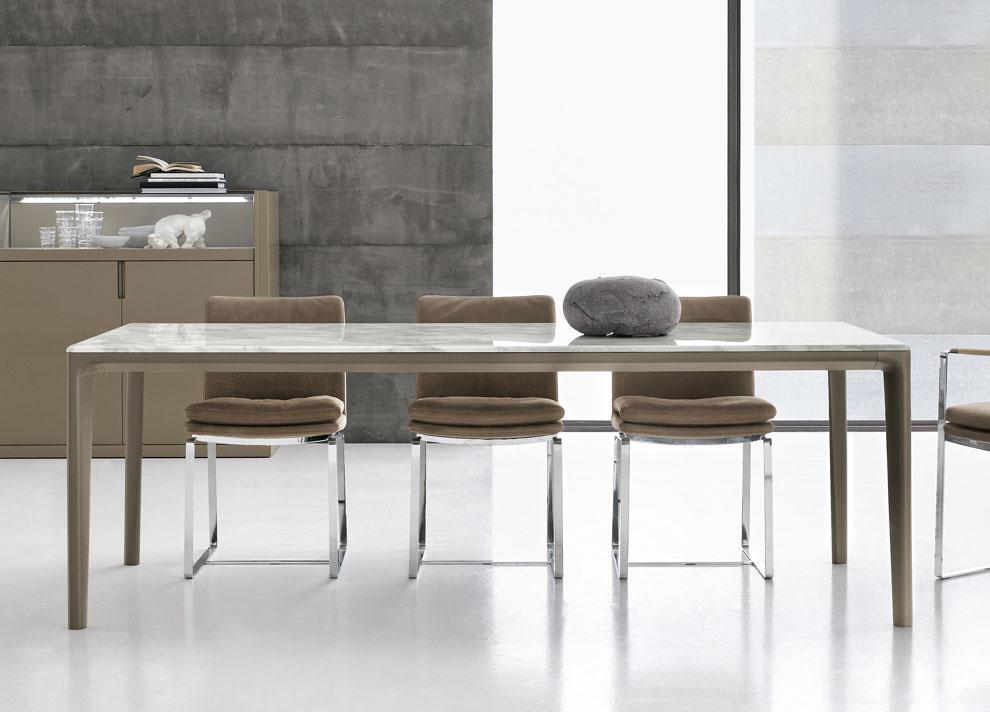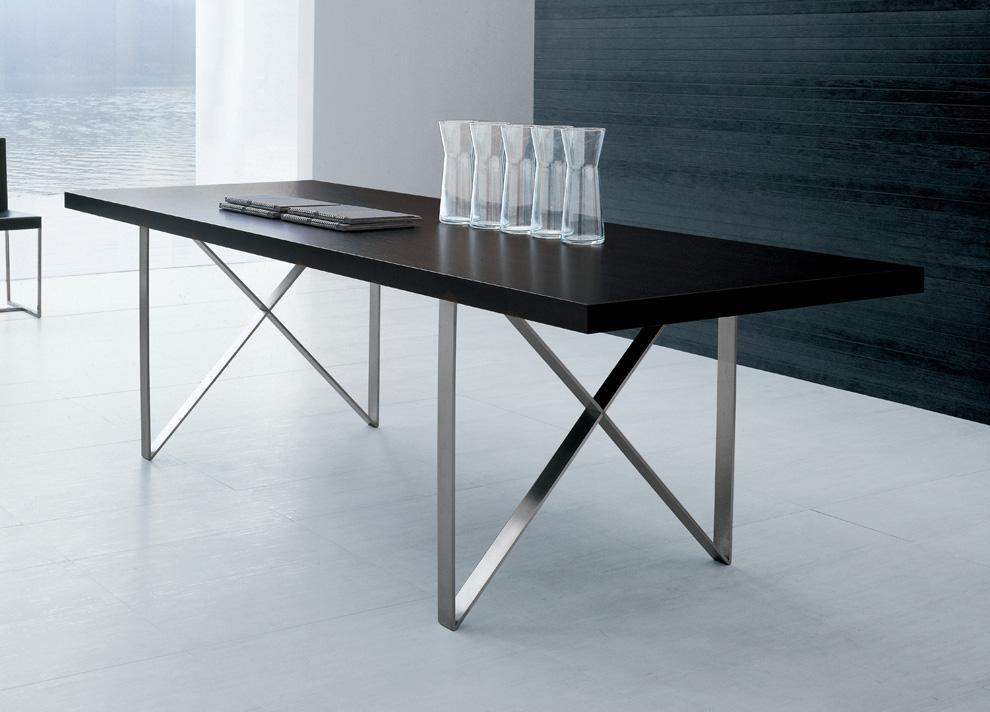The first image is the image on the left, the second image is the image on the right. Evaluate the accuracy of this statement regarding the images: "In one image, three armchairs are positioned by a square table.". Is it true? Answer yes or no. No. 